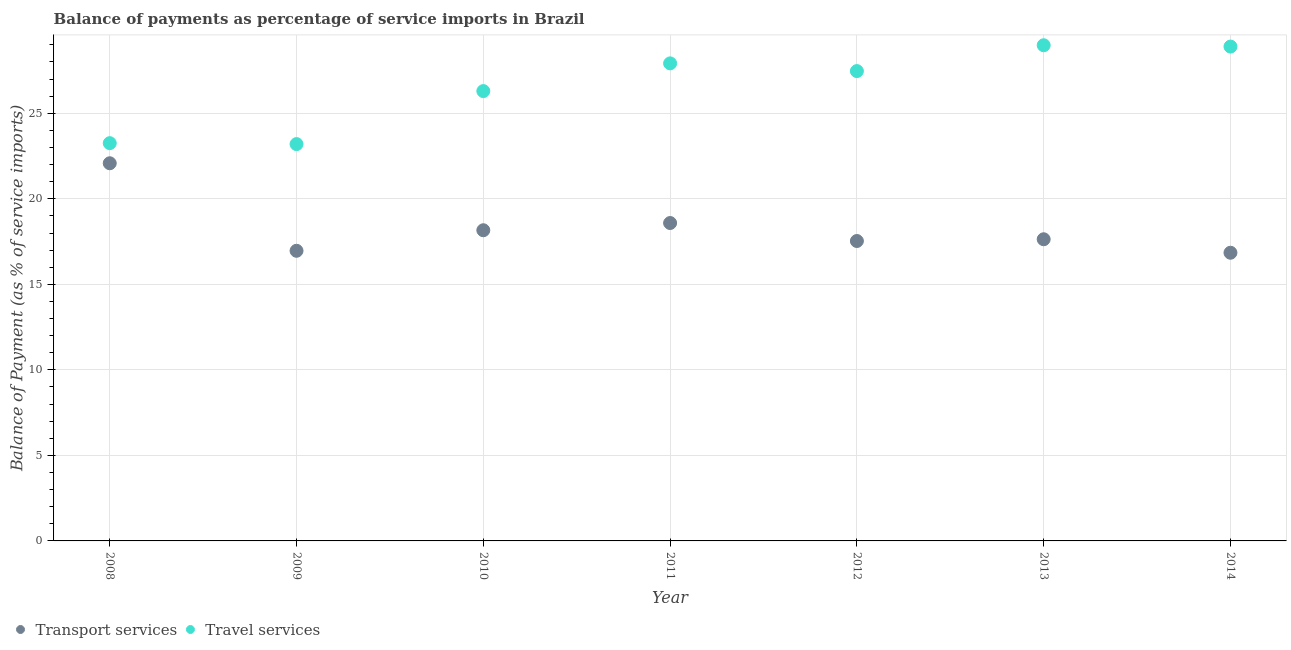How many different coloured dotlines are there?
Offer a very short reply. 2. What is the balance of payments of transport services in 2008?
Ensure brevity in your answer.  22.08. Across all years, what is the maximum balance of payments of travel services?
Make the answer very short. 28.98. Across all years, what is the minimum balance of payments of travel services?
Provide a short and direct response. 23.2. In which year was the balance of payments of travel services minimum?
Provide a short and direct response. 2009. What is the total balance of payments of transport services in the graph?
Your answer should be very brief. 127.81. What is the difference between the balance of payments of travel services in 2008 and that in 2014?
Keep it short and to the point. -5.65. What is the difference between the balance of payments of travel services in 2010 and the balance of payments of transport services in 2009?
Keep it short and to the point. 9.34. What is the average balance of payments of travel services per year?
Your response must be concise. 26.57. In the year 2012, what is the difference between the balance of payments of travel services and balance of payments of transport services?
Give a very brief answer. 9.93. In how many years, is the balance of payments of travel services greater than 18 %?
Ensure brevity in your answer.  7. What is the ratio of the balance of payments of travel services in 2008 to that in 2011?
Provide a short and direct response. 0.83. Is the difference between the balance of payments of travel services in 2011 and 2012 greater than the difference between the balance of payments of transport services in 2011 and 2012?
Give a very brief answer. No. What is the difference between the highest and the second highest balance of payments of travel services?
Give a very brief answer. 0.08. What is the difference between the highest and the lowest balance of payments of transport services?
Ensure brevity in your answer.  5.23. Is the sum of the balance of payments of transport services in 2011 and 2013 greater than the maximum balance of payments of travel services across all years?
Your response must be concise. Yes. Does the balance of payments of transport services monotonically increase over the years?
Provide a succinct answer. No. Is the balance of payments of travel services strictly greater than the balance of payments of transport services over the years?
Keep it short and to the point. Yes. Is the balance of payments of transport services strictly less than the balance of payments of travel services over the years?
Make the answer very short. Yes. How many dotlines are there?
Offer a very short reply. 2. How many years are there in the graph?
Give a very brief answer. 7. What is the difference between two consecutive major ticks on the Y-axis?
Ensure brevity in your answer.  5. Are the values on the major ticks of Y-axis written in scientific E-notation?
Provide a succinct answer. No. Does the graph contain grids?
Provide a succinct answer. Yes. Where does the legend appear in the graph?
Provide a succinct answer. Bottom left. How many legend labels are there?
Your response must be concise. 2. What is the title of the graph?
Give a very brief answer. Balance of payments as percentage of service imports in Brazil. Does "Age 15+" appear as one of the legend labels in the graph?
Provide a short and direct response. No. What is the label or title of the Y-axis?
Make the answer very short. Balance of Payment (as % of service imports). What is the Balance of Payment (as % of service imports) in Transport services in 2008?
Your answer should be very brief. 22.08. What is the Balance of Payment (as % of service imports) of Travel services in 2008?
Offer a very short reply. 23.25. What is the Balance of Payment (as % of service imports) of Transport services in 2009?
Give a very brief answer. 16.96. What is the Balance of Payment (as % of service imports) of Travel services in 2009?
Provide a short and direct response. 23.2. What is the Balance of Payment (as % of service imports) in Transport services in 2010?
Provide a succinct answer. 18.16. What is the Balance of Payment (as % of service imports) of Travel services in 2010?
Your answer should be compact. 26.3. What is the Balance of Payment (as % of service imports) in Transport services in 2011?
Make the answer very short. 18.59. What is the Balance of Payment (as % of service imports) of Travel services in 2011?
Offer a very short reply. 27.92. What is the Balance of Payment (as % of service imports) in Transport services in 2012?
Ensure brevity in your answer.  17.53. What is the Balance of Payment (as % of service imports) in Travel services in 2012?
Your answer should be compact. 27.47. What is the Balance of Payment (as % of service imports) in Transport services in 2013?
Offer a very short reply. 17.64. What is the Balance of Payment (as % of service imports) in Travel services in 2013?
Provide a succinct answer. 28.98. What is the Balance of Payment (as % of service imports) of Transport services in 2014?
Provide a short and direct response. 16.85. What is the Balance of Payment (as % of service imports) in Travel services in 2014?
Make the answer very short. 28.9. Across all years, what is the maximum Balance of Payment (as % of service imports) of Transport services?
Offer a terse response. 22.08. Across all years, what is the maximum Balance of Payment (as % of service imports) in Travel services?
Your response must be concise. 28.98. Across all years, what is the minimum Balance of Payment (as % of service imports) of Transport services?
Your response must be concise. 16.85. Across all years, what is the minimum Balance of Payment (as % of service imports) of Travel services?
Provide a short and direct response. 23.2. What is the total Balance of Payment (as % of service imports) in Transport services in the graph?
Provide a short and direct response. 127.81. What is the total Balance of Payment (as % of service imports) of Travel services in the graph?
Make the answer very short. 186.02. What is the difference between the Balance of Payment (as % of service imports) of Transport services in 2008 and that in 2009?
Your answer should be very brief. 5.12. What is the difference between the Balance of Payment (as % of service imports) in Travel services in 2008 and that in 2009?
Provide a succinct answer. 0.05. What is the difference between the Balance of Payment (as % of service imports) in Transport services in 2008 and that in 2010?
Offer a very short reply. 3.92. What is the difference between the Balance of Payment (as % of service imports) in Travel services in 2008 and that in 2010?
Give a very brief answer. -3.04. What is the difference between the Balance of Payment (as % of service imports) in Transport services in 2008 and that in 2011?
Offer a very short reply. 3.49. What is the difference between the Balance of Payment (as % of service imports) of Travel services in 2008 and that in 2011?
Ensure brevity in your answer.  -4.67. What is the difference between the Balance of Payment (as % of service imports) in Transport services in 2008 and that in 2012?
Make the answer very short. 4.55. What is the difference between the Balance of Payment (as % of service imports) of Travel services in 2008 and that in 2012?
Ensure brevity in your answer.  -4.21. What is the difference between the Balance of Payment (as % of service imports) of Transport services in 2008 and that in 2013?
Make the answer very short. 4.44. What is the difference between the Balance of Payment (as % of service imports) of Travel services in 2008 and that in 2013?
Your answer should be very brief. -5.72. What is the difference between the Balance of Payment (as % of service imports) in Transport services in 2008 and that in 2014?
Your answer should be compact. 5.23. What is the difference between the Balance of Payment (as % of service imports) in Travel services in 2008 and that in 2014?
Provide a succinct answer. -5.65. What is the difference between the Balance of Payment (as % of service imports) of Transport services in 2009 and that in 2010?
Your answer should be very brief. -1.2. What is the difference between the Balance of Payment (as % of service imports) of Travel services in 2009 and that in 2010?
Provide a succinct answer. -3.1. What is the difference between the Balance of Payment (as % of service imports) of Transport services in 2009 and that in 2011?
Keep it short and to the point. -1.62. What is the difference between the Balance of Payment (as % of service imports) of Travel services in 2009 and that in 2011?
Give a very brief answer. -4.72. What is the difference between the Balance of Payment (as % of service imports) of Transport services in 2009 and that in 2012?
Provide a short and direct response. -0.57. What is the difference between the Balance of Payment (as % of service imports) of Travel services in 2009 and that in 2012?
Ensure brevity in your answer.  -4.27. What is the difference between the Balance of Payment (as % of service imports) in Transport services in 2009 and that in 2013?
Your answer should be compact. -0.67. What is the difference between the Balance of Payment (as % of service imports) of Travel services in 2009 and that in 2013?
Make the answer very short. -5.78. What is the difference between the Balance of Payment (as % of service imports) of Transport services in 2009 and that in 2014?
Your response must be concise. 0.11. What is the difference between the Balance of Payment (as % of service imports) in Travel services in 2009 and that in 2014?
Your answer should be very brief. -5.7. What is the difference between the Balance of Payment (as % of service imports) in Transport services in 2010 and that in 2011?
Make the answer very short. -0.42. What is the difference between the Balance of Payment (as % of service imports) in Travel services in 2010 and that in 2011?
Offer a very short reply. -1.62. What is the difference between the Balance of Payment (as % of service imports) in Transport services in 2010 and that in 2012?
Offer a terse response. 0.63. What is the difference between the Balance of Payment (as % of service imports) in Travel services in 2010 and that in 2012?
Your answer should be very brief. -1.17. What is the difference between the Balance of Payment (as % of service imports) of Transport services in 2010 and that in 2013?
Ensure brevity in your answer.  0.53. What is the difference between the Balance of Payment (as % of service imports) in Travel services in 2010 and that in 2013?
Offer a very short reply. -2.68. What is the difference between the Balance of Payment (as % of service imports) in Transport services in 2010 and that in 2014?
Keep it short and to the point. 1.32. What is the difference between the Balance of Payment (as % of service imports) of Travel services in 2010 and that in 2014?
Provide a short and direct response. -2.6. What is the difference between the Balance of Payment (as % of service imports) in Transport services in 2011 and that in 2012?
Offer a terse response. 1.05. What is the difference between the Balance of Payment (as % of service imports) of Travel services in 2011 and that in 2012?
Your response must be concise. 0.45. What is the difference between the Balance of Payment (as % of service imports) of Transport services in 2011 and that in 2013?
Offer a terse response. 0.95. What is the difference between the Balance of Payment (as % of service imports) in Travel services in 2011 and that in 2013?
Ensure brevity in your answer.  -1.06. What is the difference between the Balance of Payment (as % of service imports) of Transport services in 2011 and that in 2014?
Ensure brevity in your answer.  1.74. What is the difference between the Balance of Payment (as % of service imports) of Travel services in 2011 and that in 2014?
Your answer should be very brief. -0.98. What is the difference between the Balance of Payment (as % of service imports) of Transport services in 2012 and that in 2013?
Keep it short and to the point. -0.1. What is the difference between the Balance of Payment (as % of service imports) in Travel services in 2012 and that in 2013?
Provide a succinct answer. -1.51. What is the difference between the Balance of Payment (as % of service imports) of Transport services in 2012 and that in 2014?
Your answer should be very brief. 0.69. What is the difference between the Balance of Payment (as % of service imports) in Travel services in 2012 and that in 2014?
Ensure brevity in your answer.  -1.43. What is the difference between the Balance of Payment (as % of service imports) of Transport services in 2013 and that in 2014?
Offer a terse response. 0.79. What is the difference between the Balance of Payment (as % of service imports) of Travel services in 2013 and that in 2014?
Your response must be concise. 0.08. What is the difference between the Balance of Payment (as % of service imports) of Transport services in 2008 and the Balance of Payment (as % of service imports) of Travel services in 2009?
Offer a terse response. -1.12. What is the difference between the Balance of Payment (as % of service imports) of Transport services in 2008 and the Balance of Payment (as % of service imports) of Travel services in 2010?
Your answer should be very brief. -4.22. What is the difference between the Balance of Payment (as % of service imports) of Transport services in 2008 and the Balance of Payment (as % of service imports) of Travel services in 2011?
Provide a short and direct response. -5.84. What is the difference between the Balance of Payment (as % of service imports) of Transport services in 2008 and the Balance of Payment (as % of service imports) of Travel services in 2012?
Offer a terse response. -5.39. What is the difference between the Balance of Payment (as % of service imports) in Transport services in 2008 and the Balance of Payment (as % of service imports) in Travel services in 2013?
Offer a terse response. -6.9. What is the difference between the Balance of Payment (as % of service imports) of Transport services in 2008 and the Balance of Payment (as % of service imports) of Travel services in 2014?
Give a very brief answer. -6.82. What is the difference between the Balance of Payment (as % of service imports) in Transport services in 2009 and the Balance of Payment (as % of service imports) in Travel services in 2010?
Offer a very short reply. -9.34. What is the difference between the Balance of Payment (as % of service imports) of Transport services in 2009 and the Balance of Payment (as % of service imports) of Travel services in 2011?
Your answer should be compact. -10.96. What is the difference between the Balance of Payment (as % of service imports) of Transport services in 2009 and the Balance of Payment (as % of service imports) of Travel services in 2012?
Your response must be concise. -10.51. What is the difference between the Balance of Payment (as % of service imports) of Transport services in 2009 and the Balance of Payment (as % of service imports) of Travel services in 2013?
Provide a succinct answer. -12.02. What is the difference between the Balance of Payment (as % of service imports) in Transport services in 2009 and the Balance of Payment (as % of service imports) in Travel services in 2014?
Your response must be concise. -11.94. What is the difference between the Balance of Payment (as % of service imports) of Transport services in 2010 and the Balance of Payment (as % of service imports) of Travel services in 2011?
Your answer should be very brief. -9.76. What is the difference between the Balance of Payment (as % of service imports) of Transport services in 2010 and the Balance of Payment (as % of service imports) of Travel services in 2012?
Provide a succinct answer. -9.31. What is the difference between the Balance of Payment (as % of service imports) in Transport services in 2010 and the Balance of Payment (as % of service imports) in Travel services in 2013?
Your response must be concise. -10.82. What is the difference between the Balance of Payment (as % of service imports) in Transport services in 2010 and the Balance of Payment (as % of service imports) in Travel services in 2014?
Your response must be concise. -10.74. What is the difference between the Balance of Payment (as % of service imports) of Transport services in 2011 and the Balance of Payment (as % of service imports) of Travel services in 2012?
Make the answer very short. -8.88. What is the difference between the Balance of Payment (as % of service imports) of Transport services in 2011 and the Balance of Payment (as % of service imports) of Travel services in 2013?
Keep it short and to the point. -10.39. What is the difference between the Balance of Payment (as % of service imports) in Transport services in 2011 and the Balance of Payment (as % of service imports) in Travel services in 2014?
Your answer should be compact. -10.32. What is the difference between the Balance of Payment (as % of service imports) of Transport services in 2012 and the Balance of Payment (as % of service imports) of Travel services in 2013?
Offer a terse response. -11.44. What is the difference between the Balance of Payment (as % of service imports) in Transport services in 2012 and the Balance of Payment (as % of service imports) in Travel services in 2014?
Your answer should be compact. -11.37. What is the difference between the Balance of Payment (as % of service imports) of Transport services in 2013 and the Balance of Payment (as % of service imports) of Travel services in 2014?
Give a very brief answer. -11.27. What is the average Balance of Payment (as % of service imports) in Transport services per year?
Provide a succinct answer. 18.26. What is the average Balance of Payment (as % of service imports) in Travel services per year?
Keep it short and to the point. 26.57. In the year 2008, what is the difference between the Balance of Payment (as % of service imports) in Transport services and Balance of Payment (as % of service imports) in Travel services?
Ensure brevity in your answer.  -1.18. In the year 2009, what is the difference between the Balance of Payment (as % of service imports) of Transport services and Balance of Payment (as % of service imports) of Travel services?
Give a very brief answer. -6.24. In the year 2010, what is the difference between the Balance of Payment (as % of service imports) of Transport services and Balance of Payment (as % of service imports) of Travel services?
Keep it short and to the point. -8.14. In the year 2011, what is the difference between the Balance of Payment (as % of service imports) of Transport services and Balance of Payment (as % of service imports) of Travel services?
Ensure brevity in your answer.  -9.33. In the year 2012, what is the difference between the Balance of Payment (as % of service imports) of Transport services and Balance of Payment (as % of service imports) of Travel services?
Your response must be concise. -9.93. In the year 2013, what is the difference between the Balance of Payment (as % of service imports) in Transport services and Balance of Payment (as % of service imports) in Travel services?
Offer a terse response. -11.34. In the year 2014, what is the difference between the Balance of Payment (as % of service imports) of Transport services and Balance of Payment (as % of service imports) of Travel services?
Make the answer very short. -12.05. What is the ratio of the Balance of Payment (as % of service imports) of Transport services in 2008 to that in 2009?
Your answer should be compact. 1.3. What is the ratio of the Balance of Payment (as % of service imports) in Transport services in 2008 to that in 2010?
Provide a succinct answer. 1.22. What is the ratio of the Balance of Payment (as % of service imports) in Travel services in 2008 to that in 2010?
Offer a very short reply. 0.88. What is the ratio of the Balance of Payment (as % of service imports) of Transport services in 2008 to that in 2011?
Keep it short and to the point. 1.19. What is the ratio of the Balance of Payment (as % of service imports) of Travel services in 2008 to that in 2011?
Make the answer very short. 0.83. What is the ratio of the Balance of Payment (as % of service imports) in Transport services in 2008 to that in 2012?
Provide a succinct answer. 1.26. What is the ratio of the Balance of Payment (as % of service imports) of Travel services in 2008 to that in 2012?
Ensure brevity in your answer.  0.85. What is the ratio of the Balance of Payment (as % of service imports) of Transport services in 2008 to that in 2013?
Your response must be concise. 1.25. What is the ratio of the Balance of Payment (as % of service imports) of Travel services in 2008 to that in 2013?
Offer a terse response. 0.8. What is the ratio of the Balance of Payment (as % of service imports) in Transport services in 2008 to that in 2014?
Your response must be concise. 1.31. What is the ratio of the Balance of Payment (as % of service imports) of Travel services in 2008 to that in 2014?
Ensure brevity in your answer.  0.8. What is the ratio of the Balance of Payment (as % of service imports) of Transport services in 2009 to that in 2010?
Provide a succinct answer. 0.93. What is the ratio of the Balance of Payment (as % of service imports) of Travel services in 2009 to that in 2010?
Provide a succinct answer. 0.88. What is the ratio of the Balance of Payment (as % of service imports) in Transport services in 2009 to that in 2011?
Your response must be concise. 0.91. What is the ratio of the Balance of Payment (as % of service imports) of Travel services in 2009 to that in 2011?
Make the answer very short. 0.83. What is the ratio of the Balance of Payment (as % of service imports) in Transport services in 2009 to that in 2012?
Your answer should be compact. 0.97. What is the ratio of the Balance of Payment (as % of service imports) of Travel services in 2009 to that in 2012?
Offer a terse response. 0.84. What is the ratio of the Balance of Payment (as % of service imports) in Transport services in 2009 to that in 2013?
Provide a short and direct response. 0.96. What is the ratio of the Balance of Payment (as % of service imports) in Travel services in 2009 to that in 2013?
Your answer should be compact. 0.8. What is the ratio of the Balance of Payment (as % of service imports) of Transport services in 2009 to that in 2014?
Your response must be concise. 1.01. What is the ratio of the Balance of Payment (as % of service imports) of Travel services in 2009 to that in 2014?
Keep it short and to the point. 0.8. What is the ratio of the Balance of Payment (as % of service imports) of Transport services in 2010 to that in 2011?
Your response must be concise. 0.98. What is the ratio of the Balance of Payment (as % of service imports) of Travel services in 2010 to that in 2011?
Provide a short and direct response. 0.94. What is the ratio of the Balance of Payment (as % of service imports) of Transport services in 2010 to that in 2012?
Your response must be concise. 1.04. What is the ratio of the Balance of Payment (as % of service imports) in Travel services in 2010 to that in 2012?
Keep it short and to the point. 0.96. What is the ratio of the Balance of Payment (as % of service imports) in Transport services in 2010 to that in 2013?
Make the answer very short. 1.03. What is the ratio of the Balance of Payment (as % of service imports) of Travel services in 2010 to that in 2013?
Provide a succinct answer. 0.91. What is the ratio of the Balance of Payment (as % of service imports) in Transport services in 2010 to that in 2014?
Provide a short and direct response. 1.08. What is the ratio of the Balance of Payment (as % of service imports) in Travel services in 2010 to that in 2014?
Your answer should be very brief. 0.91. What is the ratio of the Balance of Payment (as % of service imports) in Transport services in 2011 to that in 2012?
Provide a short and direct response. 1.06. What is the ratio of the Balance of Payment (as % of service imports) of Travel services in 2011 to that in 2012?
Provide a succinct answer. 1.02. What is the ratio of the Balance of Payment (as % of service imports) in Transport services in 2011 to that in 2013?
Your answer should be compact. 1.05. What is the ratio of the Balance of Payment (as % of service imports) in Travel services in 2011 to that in 2013?
Make the answer very short. 0.96. What is the ratio of the Balance of Payment (as % of service imports) in Transport services in 2011 to that in 2014?
Keep it short and to the point. 1.1. What is the ratio of the Balance of Payment (as % of service imports) of Transport services in 2012 to that in 2013?
Give a very brief answer. 0.99. What is the ratio of the Balance of Payment (as % of service imports) of Travel services in 2012 to that in 2013?
Provide a succinct answer. 0.95. What is the ratio of the Balance of Payment (as % of service imports) in Transport services in 2012 to that in 2014?
Give a very brief answer. 1.04. What is the ratio of the Balance of Payment (as % of service imports) of Travel services in 2012 to that in 2014?
Your answer should be very brief. 0.95. What is the ratio of the Balance of Payment (as % of service imports) of Transport services in 2013 to that in 2014?
Provide a short and direct response. 1.05. What is the difference between the highest and the second highest Balance of Payment (as % of service imports) of Transport services?
Provide a short and direct response. 3.49. What is the difference between the highest and the second highest Balance of Payment (as % of service imports) in Travel services?
Provide a succinct answer. 0.08. What is the difference between the highest and the lowest Balance of Payment (as % of service imports) in Transport services?
Provide a short and direct response. 5.23. What is the difference between the highest and the lowest Balance of Payment (as % of service imports) of Travel services?
Make the answer very short. 5.78. 